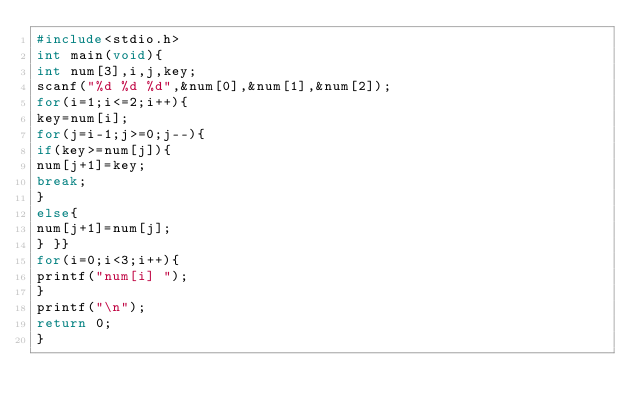<code> <loc_0><loc_0><loc_500><loc_500><_C_>#include<stdio.h>
int main(void){
int num[3],i,j,key;
scanf("%d %d %d",&num[0],&num[1],&num[2]);
for(i=1;i<=2;i++){
key=num[i];
for(j=i-1;j>=0;j--){
if(key>=num[j]){
num[j+1]=key;
break;
}
else{
num[j+1]=num[j];
} }}
for(i=0;i<3;i++){
printf("num[i] ");
}
printf("\n");
return 0;
}</code> 